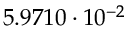Convert formula to latex. <formula><loc_0><loc_0><loc_500><loc_500>5 . 9 7 1 0 \cdot 1 0 ^ { - 2 }</formula> 